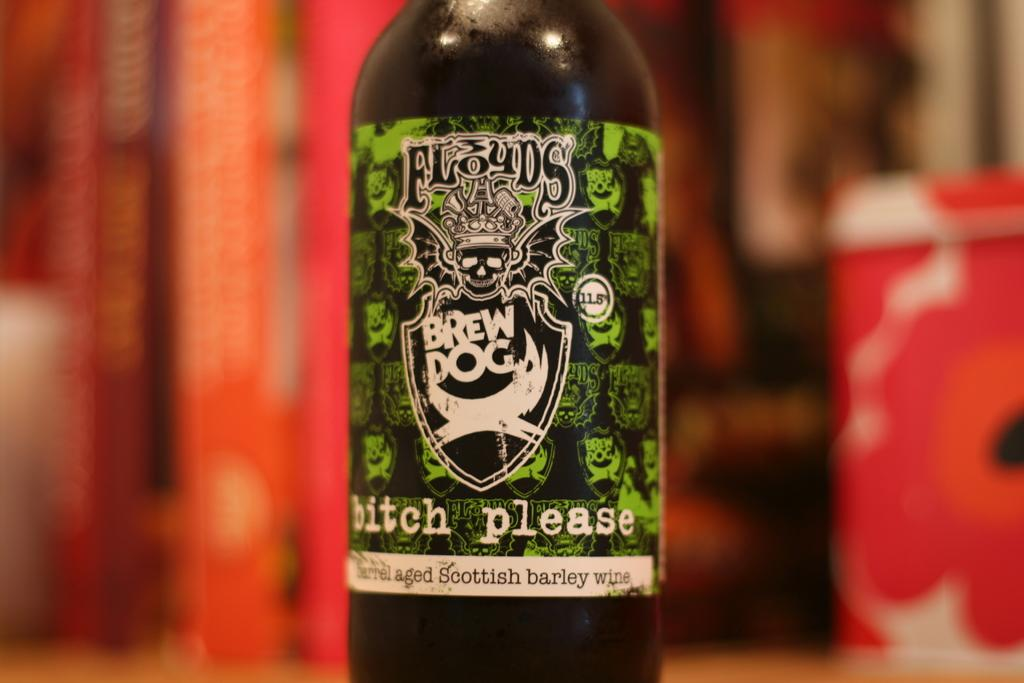<image>
Describe the image concisely. the name bitch please that is on a bottle 